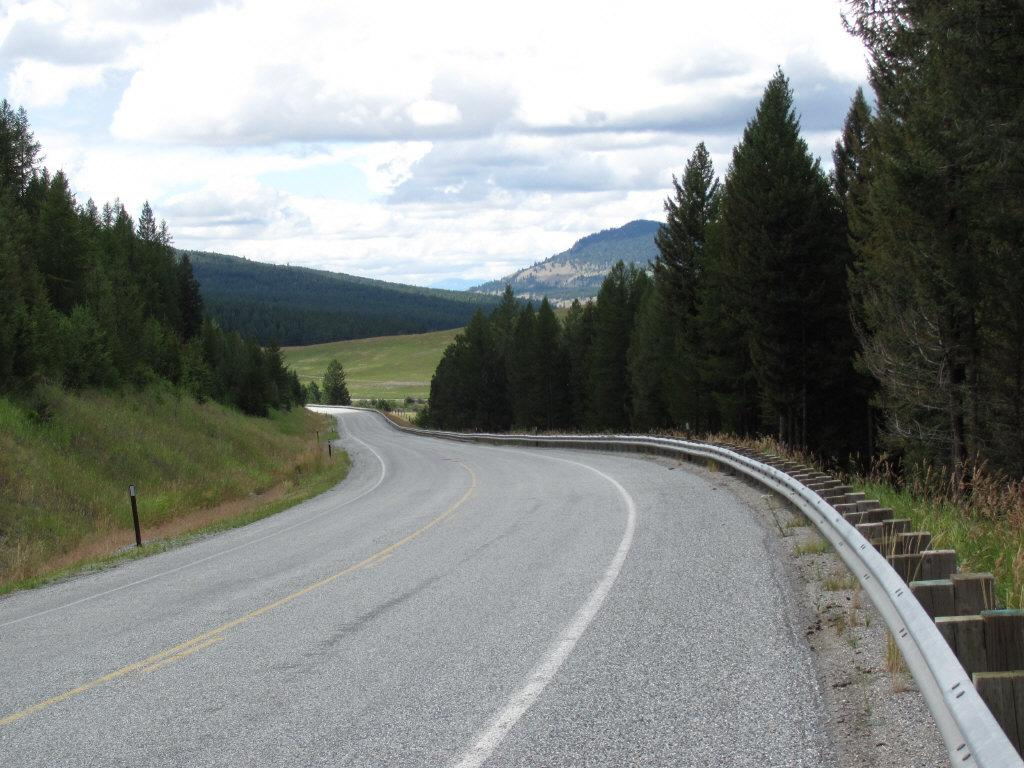What is the main feature of the image? There is a road in the image. What can be seen alongside the road? There are trees on both sides of the road. What is visible in the distance in the image? There are hills visible in the background of the image. What type of destruction can be seen happening in the town in the image? There is no town or destruction present in the image; it features a road with trees on both sides and hills in the background. 